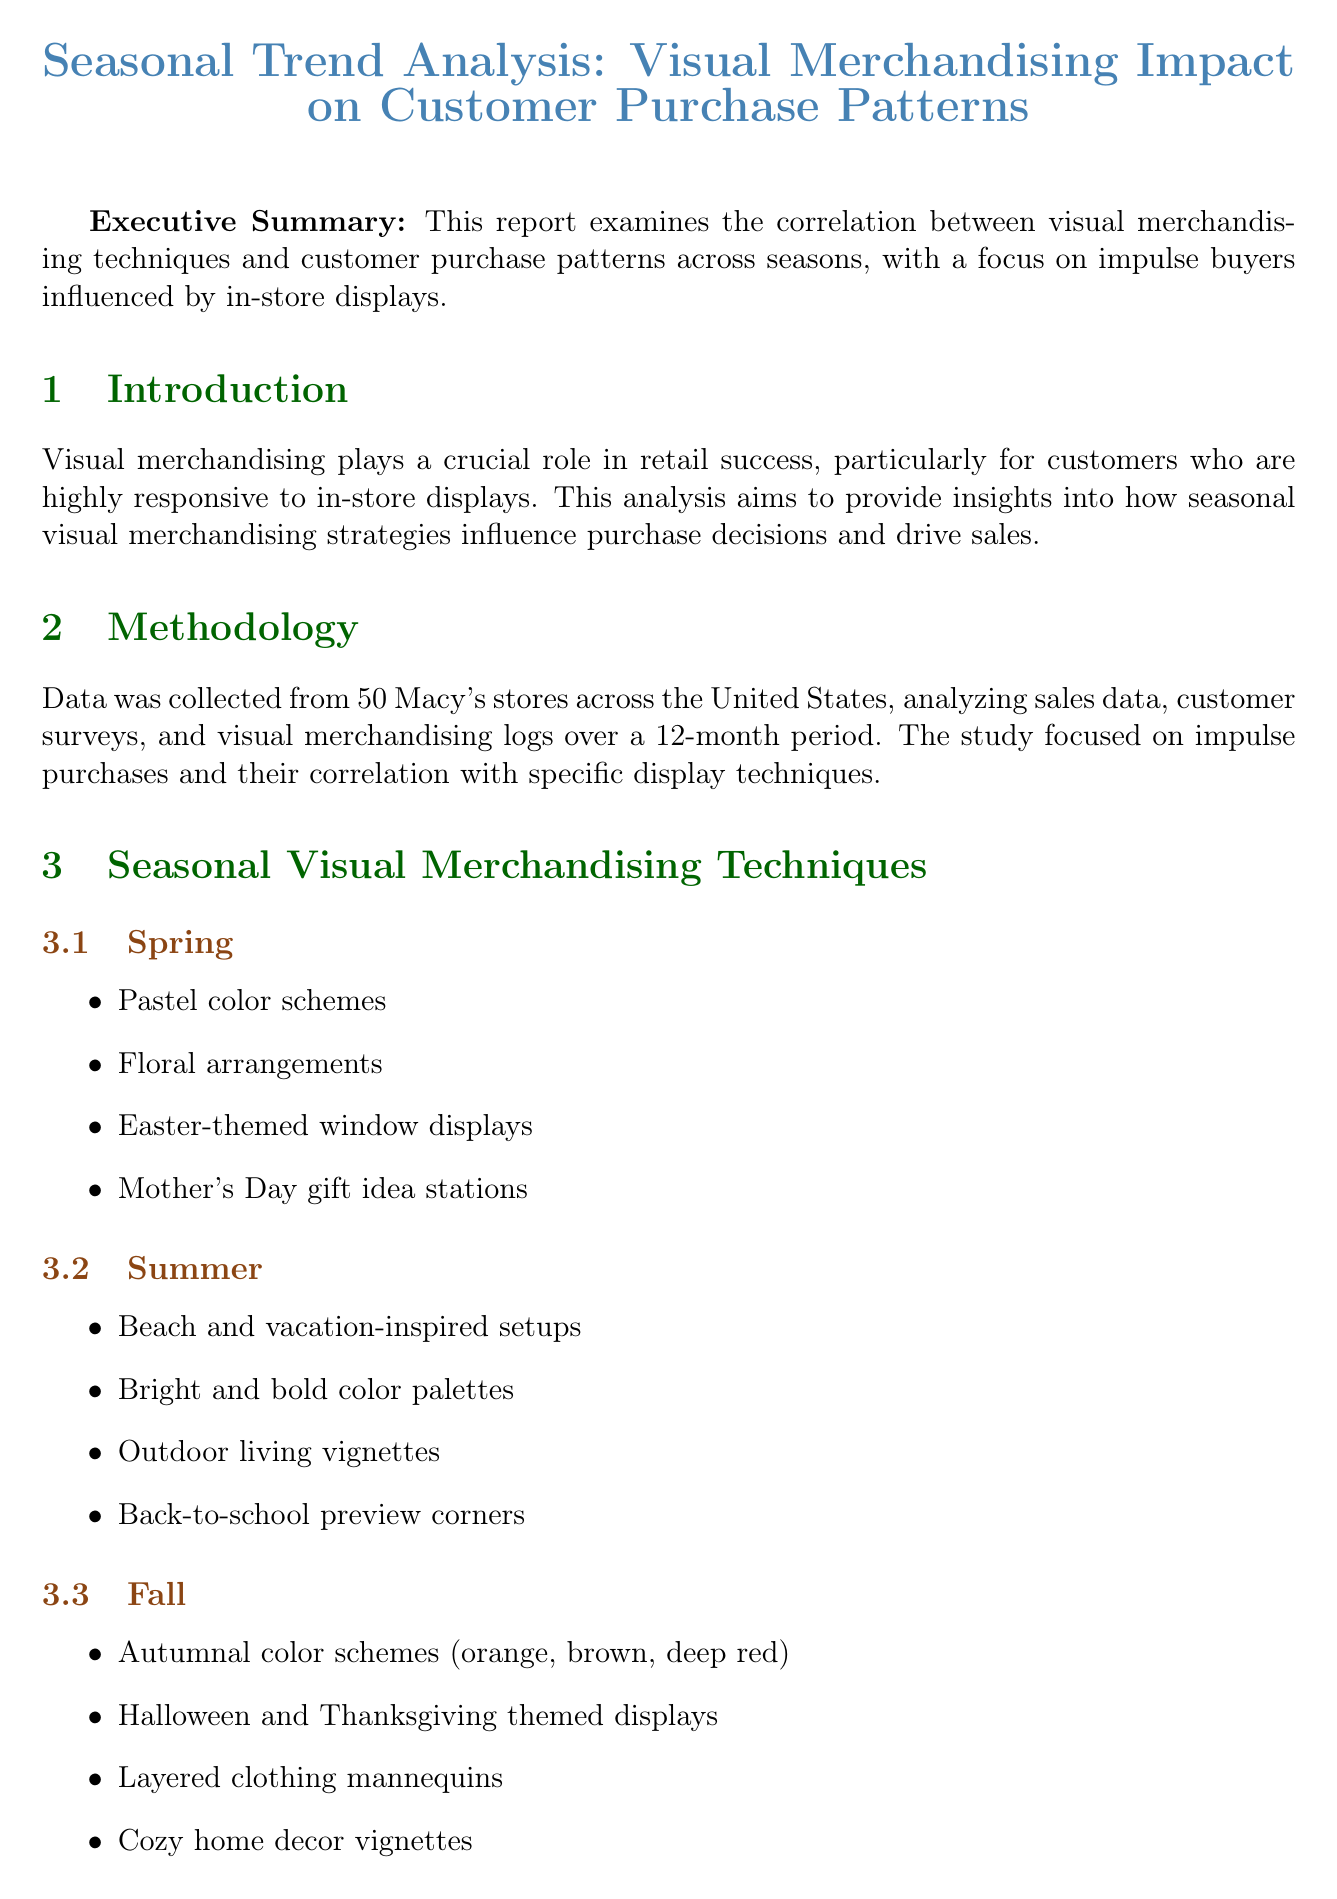what is the main focus of the report? The report examines the correlation between visual merchandising techniques and customer purchase patterns, particularly for impulse buyers.
Answer: correlation between visual merchandising techniques and customer purchase patterns which season features “Easter-themed window displays”? This technique is listed under the Spring section of the Seasonal Visual Merchandising Techniques.
Answer: Spring how much did impulse purchases increase with seasonal themes? This percentage is highlighted in the Customer Purchase Patterns Analysis section of the report.
Answer: 27% what was the result of the interactive holiday window displays at Macy's Herald Square? This result is mentioned in the Case Studies section, detailing the impact of the merchandising technique at a specific store.
Answer: 18% increase in foot traffic and 23% boost in sales of featured products how long was customer dwell time in themed areas compared to non-themed sections? This information is provided in the Customer Purchase Patterns Analysis section, indicating how themed areas performed regarding customer engagement.
Answer: 45% longer what is one recommended strategy for engaging impulse shoppers? This recommendation is listed under the Recommendations section of the report, offering actionable insights for retailers.
Answer: Implement dynamic and interactive displays why are complementary items placed strategically? This reasoning is inferred from the key findings in the Customer Purchase Patterns Analysis, emphasizing the effectiveness of display technique.
Answer: To improve cross-selling success rates by 35% what is featured in “Mother's Day gift idea stations”? This specific display technique is mentioned in the Spring section of the report as part of its visual merchandising techniques.
Answer: Mother's Day gift idea stations 